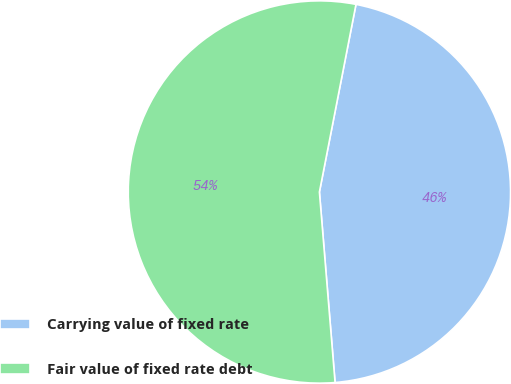Convert chart. <chart><loc_0><loc_0><loc_500><loc_500><pie_chart><fcel>Carrying value of fixed rate<fcel>Fair value of fixed rate debt<nl><fcel>45.63%<fcel>54.37%<nl></chart> 